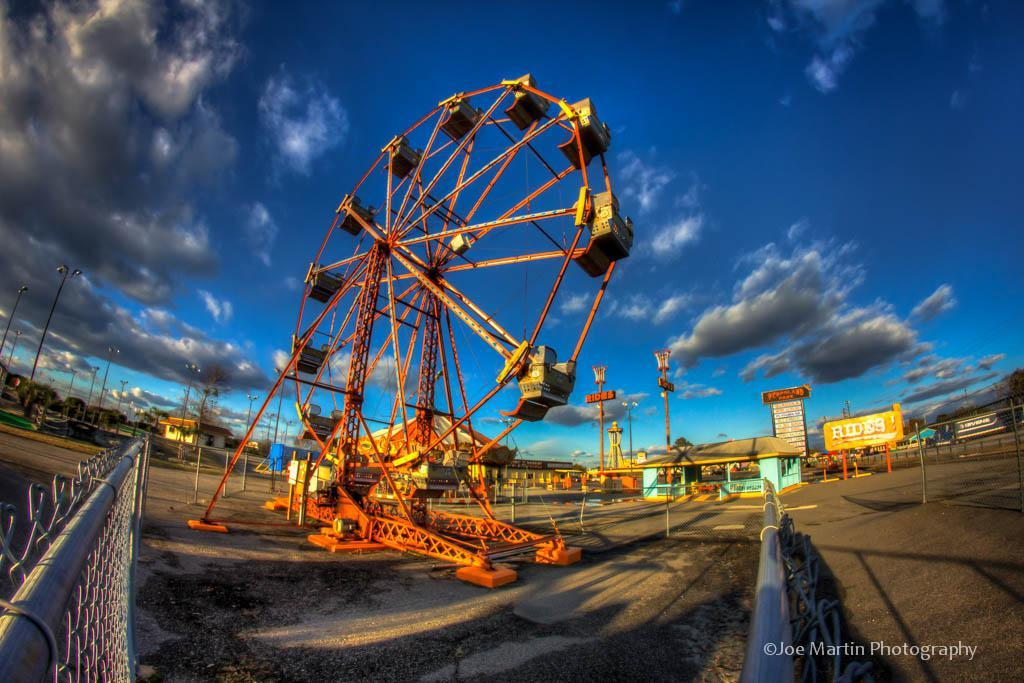What is the main subject in the middle of the picture? There is a giant wheel in the middle of the picture. What can be seen in the background of the image? There are clouds in the sky in the background of the image. How many snails can be seen flying around the giant wheel? There are no snails present in the image, and snails cannot fly. 